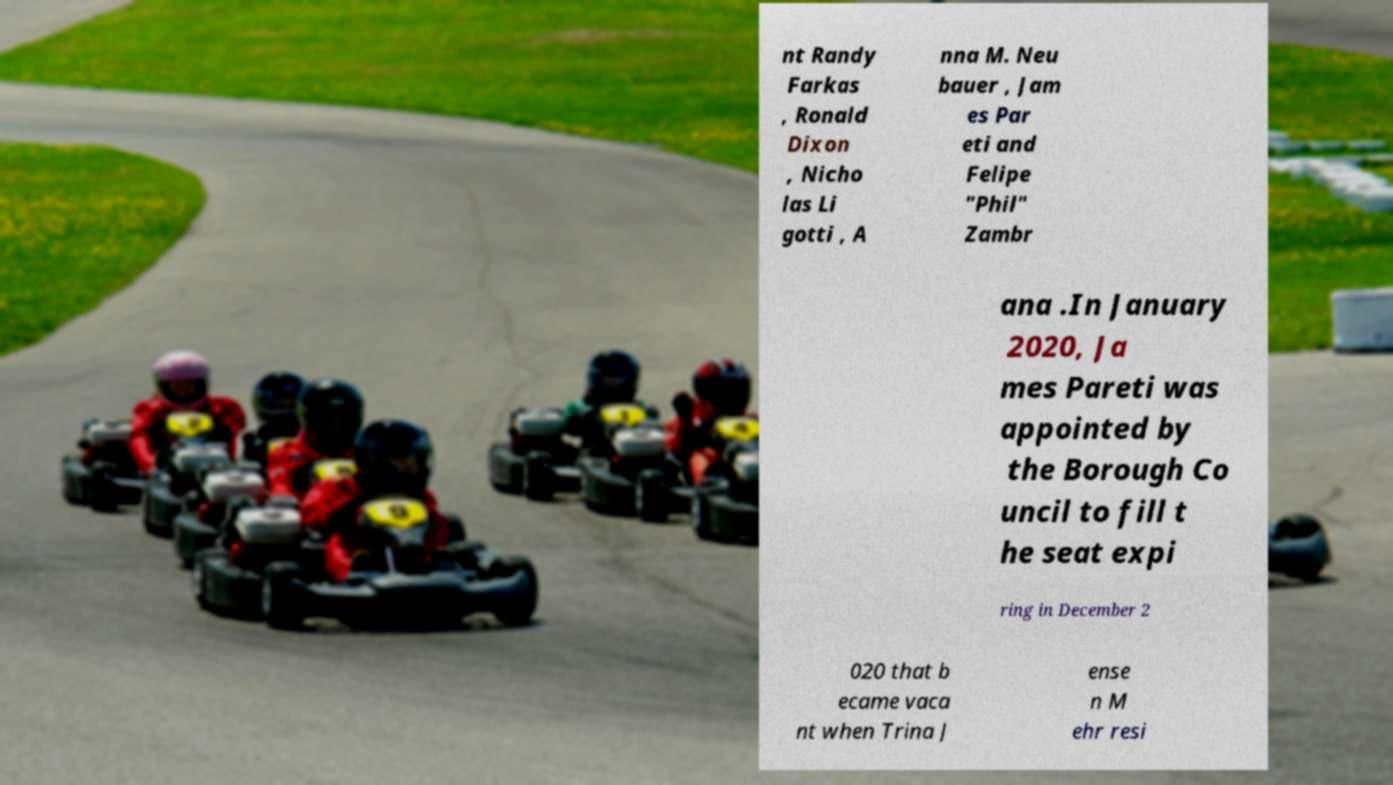Can you accurately transcribe the text from the provided image for me? nt Randy Farkas , Ronald Dixon , Nicho las Li gotti , A nna M. Neu bauer , Jam es Par eti and Felipe "Phil" Zambr ana .In January 2020, Ja mes Pareti was appointed by the Borough Co uncil to fill t he seat expi ring in December 2 020 that b ecame vaca nt when Trina J ense n M ehr resi 